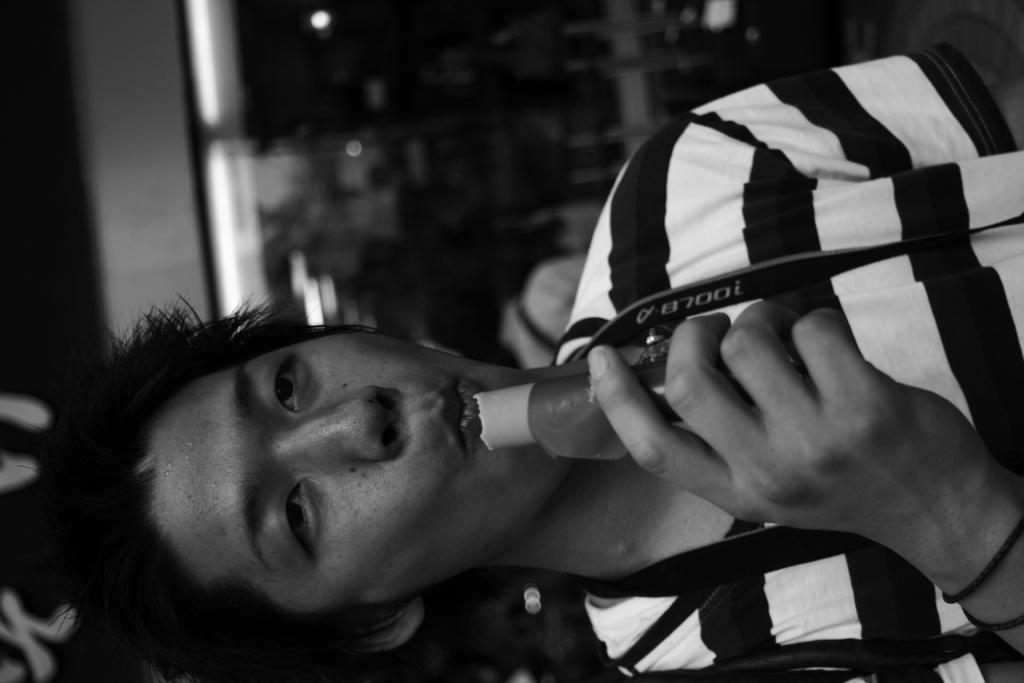What can be seen in the image? There is a person in the image. What is the person doing in the image? The person is holding an object. Can you describe the background of the image? The background appears blurry. How many planes can be seen flying in the background of the image? There are no planes visible in the image; the background appears blurry. 